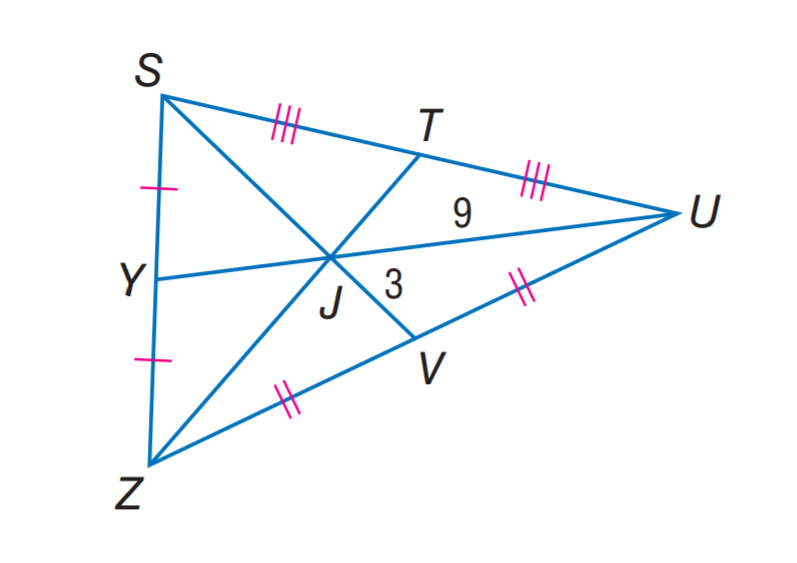Answer the mathemtical geometry problem and directly provide the correct option letter.
Question: U J = 9, V J = 3, and Z T = 18. Find Z J.
Choices: A: 3 B: 6 C: 9 D: 12 D 